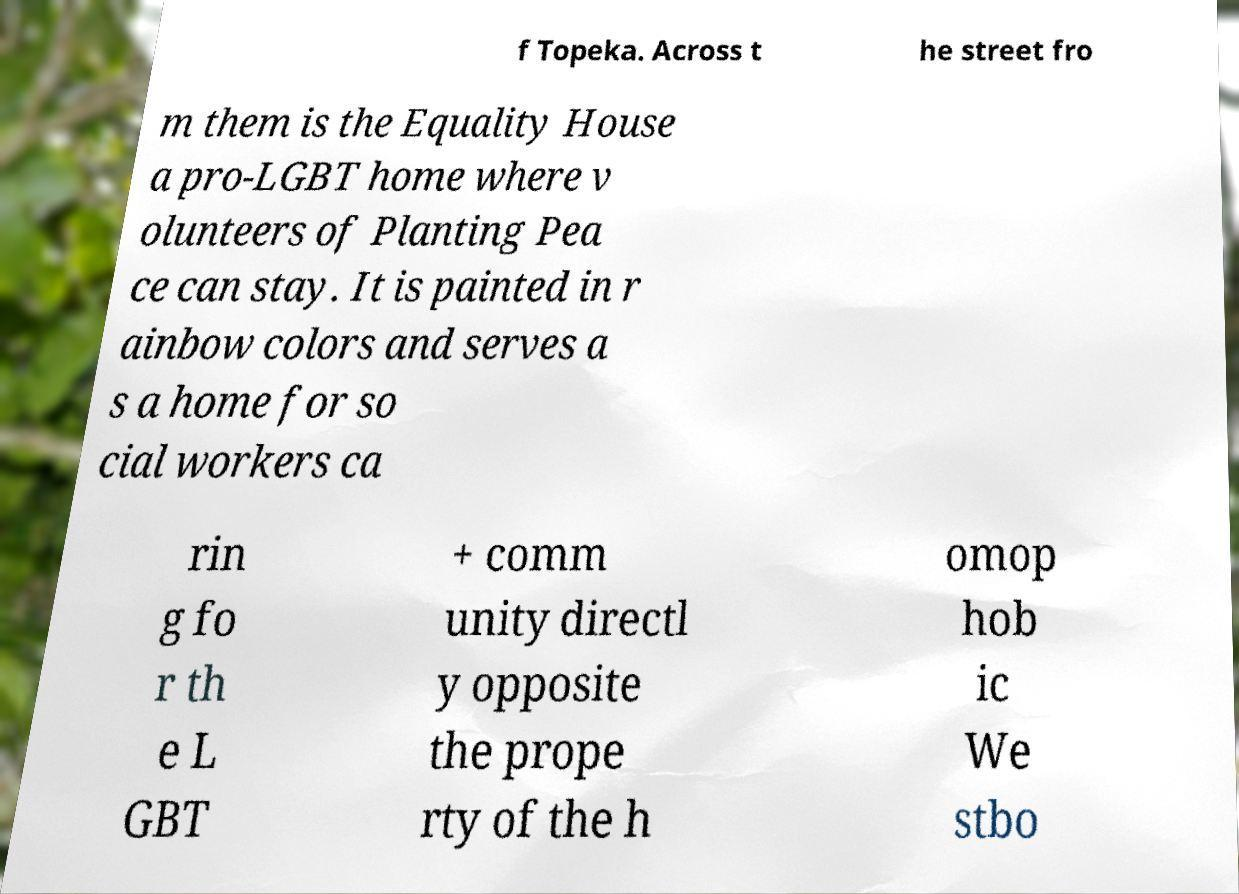Can you read and provide the text displayed in the image?This photo seems to have some interesting text. Can you extract and type it out for me? f Topeka. Across t he street fro m them is the Equality House a pro-LGBT home where v olunteers of Planting Pea ce can stay. It is painted in r ainbow colors and serves a s a home for so cial workers ca rin g fo r th e L GBT + comm unity directl y opposite the prope rty of the h omop hob ic We stbo 